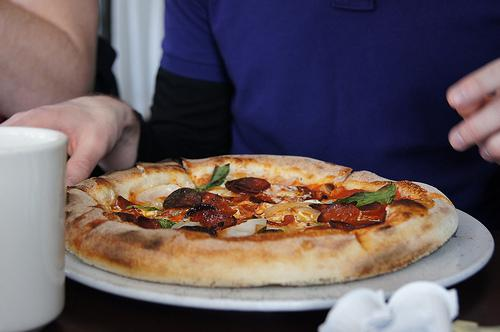Question: what food is shown here?
Choices:
A. Burger.
B. Pizza.
C. Fries.
D. Ice cream.
Answer with the letter. Answer: B Question: where was this picture likely taken?
Choices:
A. Hotel.
B. A restaurant.
C. House.
D. Hospital.
Answer with the letter. Answer: B Question: what color is the plate the pizza is sitting on?
Choices:
A. Blue.
B. Silver.
C. White.
D. Black.
Answer with the letter. Answer: C Question: what color shirt is the diner wearing?
Choices:
A. White.
B. Black.
C. Pink.
D. Blue.
Answer with the letter. Answer: D Question: how many slices is the pizza sliced into?
Choices:
A. Six.
B. Four.
C. Eight.
D. Two.
Answer with the letter. Answer: A Question: what color is the table in the picture?
Choices:
A. Brown.
B. Black.
C. White.
D. Blue.
Answer with the letter. Answer: B 